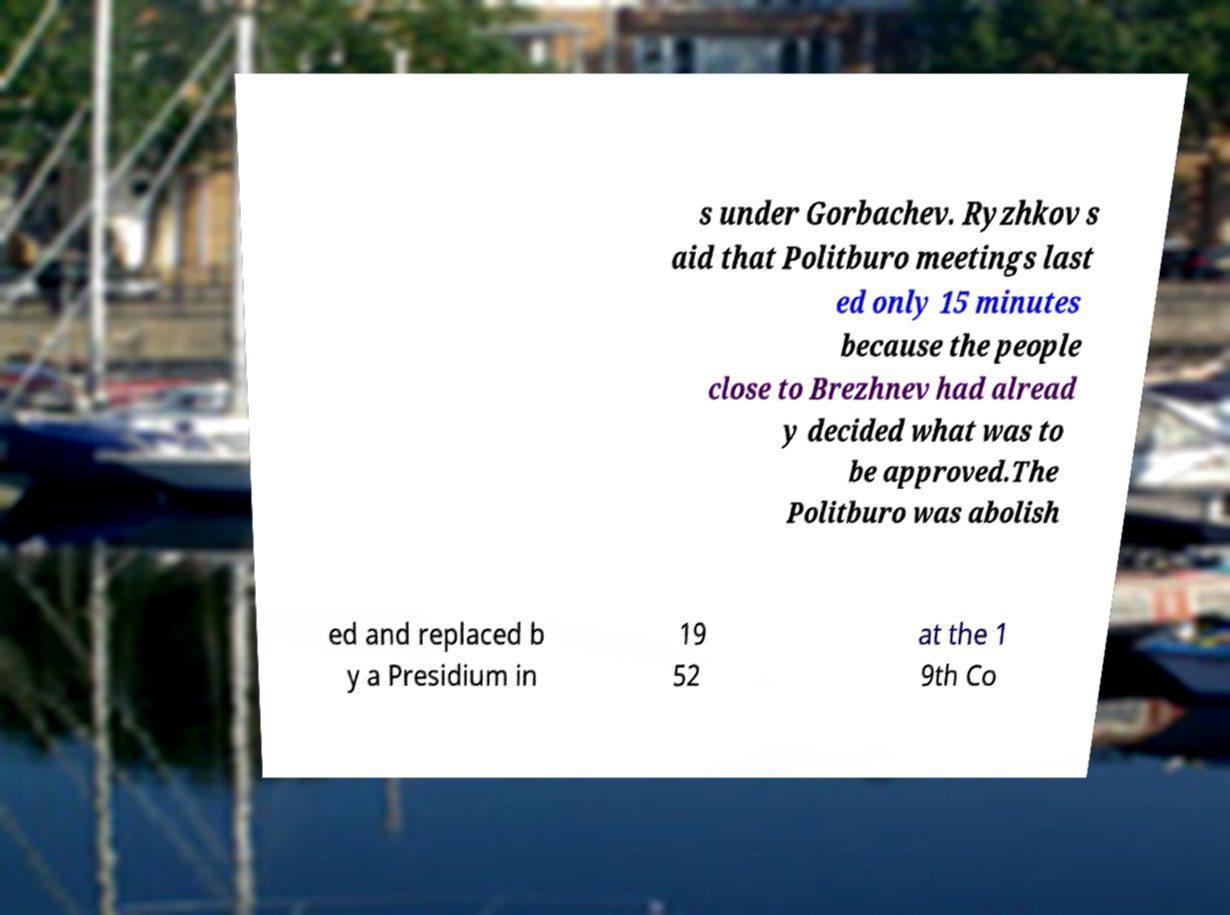Can you accurately transcribe the text from the provided image for me? s under Gorbachev. Ryzhkov s aid that Politburo meetings last ed only 15 minutes because the people close to Brezhnev had alread y decided what was to be approved.The Politburo was abolish ed and replaced b y a Presidium in 19 52 at the 1 9th Co 